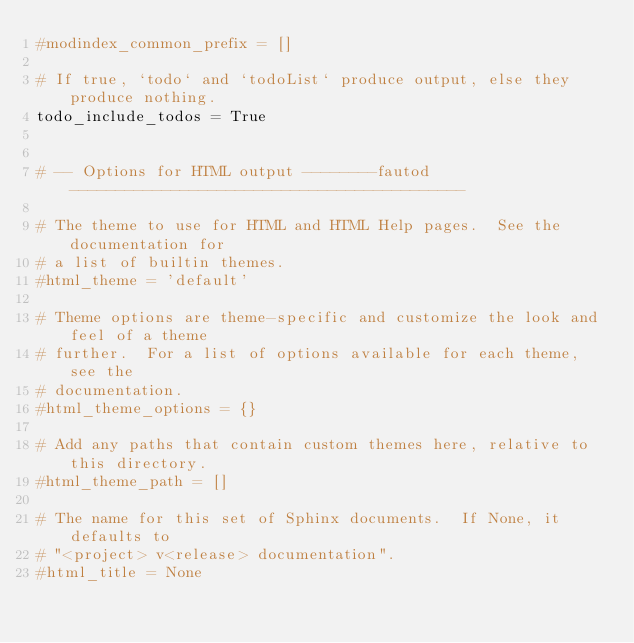<code> <loc_0><loc_0><loc_500><loc_500><_Python_>#modindex_common_prefix = []

# If true, `todo` and `todoList` produce output, else they produce nothing.
todo_include_todos = True


# -- Options for HTML output --------fautod-------------------------------------------

# The theme to use for HTML and HTML Help pages.  See the documentation for
# a list of builtin themes.
#html_theme = 'default'

# Theme options are theme-specific and customize the look and feel of a theme
# further.  For a list of options available for each theme, see the
# documentation.
#html_theme_options = {}

# Add any paths that contain custom themes here, relative to this directory.
#html_theme_path = []

# The name for this set of Sphinx documents.  If None, it defaults to
# "<project> v<release> documentation".
#html_title = None
</code> 